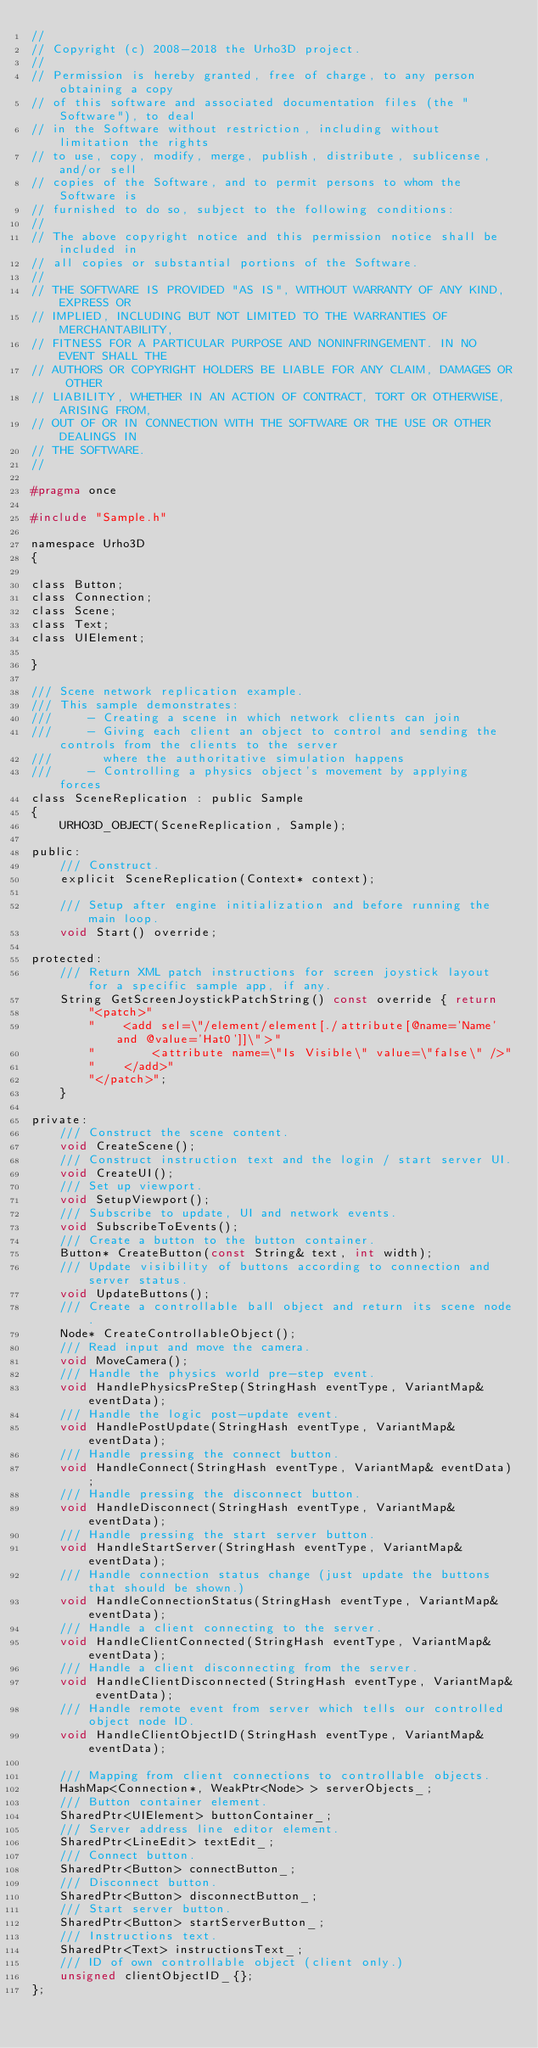Convert code to text. <code><loc_0><loc_0><loc_500><loc_500><_C_>//
// Copyright (c) 2008-2018 the Urho3D project.
//
// Permission is hereby granted, free of charge, to any person obtaining a copy
// of this software and associated documentation files (the "Software"), to deal
// in the Software without restriction, including without limitation the rights
// to use, copy, modify, merge, publish, distribute, sublicense, and/or sell
// copies of the Software, and to permit persons to whom the Software is
// furnished to do so, subject to the following conditions:
//
// The above copyright notice and this permission notice shall be included in
// all copies or substantial portions of the Software.
//
// THE SOFTWARE IS PROVIDED "AS IS", WITHOUT WARRANTY OF ANY KIND, EXPRESS OR
// IMPLIED, INCLUDING BUT NOT LIMITED TO THE WARRANTIES OF MERCHANTABILITY,
// FITNESS FOR A PARTICULAR PURPOSE AND NONINFRINGEMENT. IN NO EVENT SHALL THE
// AUTHORS OR COPYRIGHT HOLDERS BE LIABLE FOR ANY CLAIM, DAMAGES OR OTHER
// LIABILITY, WHETHER IN AN ACTION OF CONTRACT, TORT OR OTHERWISE, ARISING FROM,
// OUT OF OR IN CONNECTION WITH THE SOFTWARE OR THE USE OR OTHER DEALINGS IN
// THE SOFTWARE.
//

#pragma once

#include "Sample.h"

namespace Urho3D
{

class Button;
class Connection;
class Scene;
class Text;
class UIElement;

}

/// Scene network replication example.
/// This sample demonstrates:
///     - Creating a scene in which network clients can join
///     - Giving each client an object to control and sending the controls from the clients to the server
///       where the authoritative simulation happens
///     - Controlling a physics object's movement by applying forces
class SceneReplication : public Sample
{
    URHO3D_OBJECT(SceneReplication, Sample);

public:
    /// Construct.
    explicit SceneReplication(Context* context);

    /// Setup after engine initialization and before running the main loop.
    void Start() override;

protected:
    /// Return XML patch instructions for screen joystick layout for a specific sample app, if any.
    String GetScreenJoystickPatchString() const override { return
        "<patch>"
        "    <add sel=\"/element/element[./attribute[@name='Name' and @value='Hat0']]\">"
        "        <attribute name=\"Is Visible\" value=\"false\" />"
        "    </add>"
        "</patch>";
    }

private:
    /// Construct the scene content.
    void CreateScene();
    /// Construct instruction text and the login / start server UI.
    void CreateUI();
    /// Set up viewport.
    void SetupViewport();
    /// Subscribe to update, UI and network events.
    void SubscribeToEvents();
    /// Create a button to the button container.
    Button* CreateButton(const String& text, int width);
    /// Update visibility of buttons according to connection and server status.
    void UpdateButtons();
    /// Create a controllable ball object and return its scene node.
    Node* CreateControllableObject();
    /// Read input and move the camera.
    void MoveCamera();
    /// Handle the physics world pre-step event.
    void HandlePhysicsPreStep(StringHash eventType, VariantMap& eventData);
    /// Handle the logic post-update event.
    void HandlePostUpdate(StringHash eventType, VariantMap& eventData);
    /// Handle pressing the connect button.
    void HandleConnect(StringHash eventType, VariantMap& eventData);
    /// Handle pressing the disconnect button.
    void HandleDisconnect(StringHash eventType, VariantMap& eventData);
    /// Handle pressing the start server button.
    void HandleStartServer(StringHash eventType, VariantMap& eventData);
    /// Handle connection status change (just update the buttons that should be shown.)
    void HandleConnectionStatus(StringHash eventType, VariantMap& eventData);
    /// Handle a client connecting to the server.
    void HandleClientConnected(StringHash eventType, VariantMap& eventData);
    /// Handle a client disconnecting from the server.
    void HandleClientDisconnected(StringHash eventType, VariantMap& eventData);
    /// Handle remote event from server which tells our controlled object node ID.
    void HandleClientObjectID(StringHash eventType, VariantMap& eventData);

    /// Mapping from client connections to controllable objects.
    HashMap<Connection*, WeakPtr<Node> > serverObjects_;
    /// Button container element.
    SharedPtr<UIElement> buttonContainer_;
    /// Server address line editor element.
    SharedPtr<LineEdit> textEdit_;
    /// Connect button.
    SharedPtr<Button> connectButton_;
    /// Disconnect button.
    SharedPtr<Button> disconnectButton_;
    /// Start server button.
    SharedPtr<Button> startServerButton_;
    /// Instructions text.
    SharedPtr<Text> instructionsText_;
    /// ID of own controllable object (client only.)
    unsigned clientObjectID_{};
};
</code> 